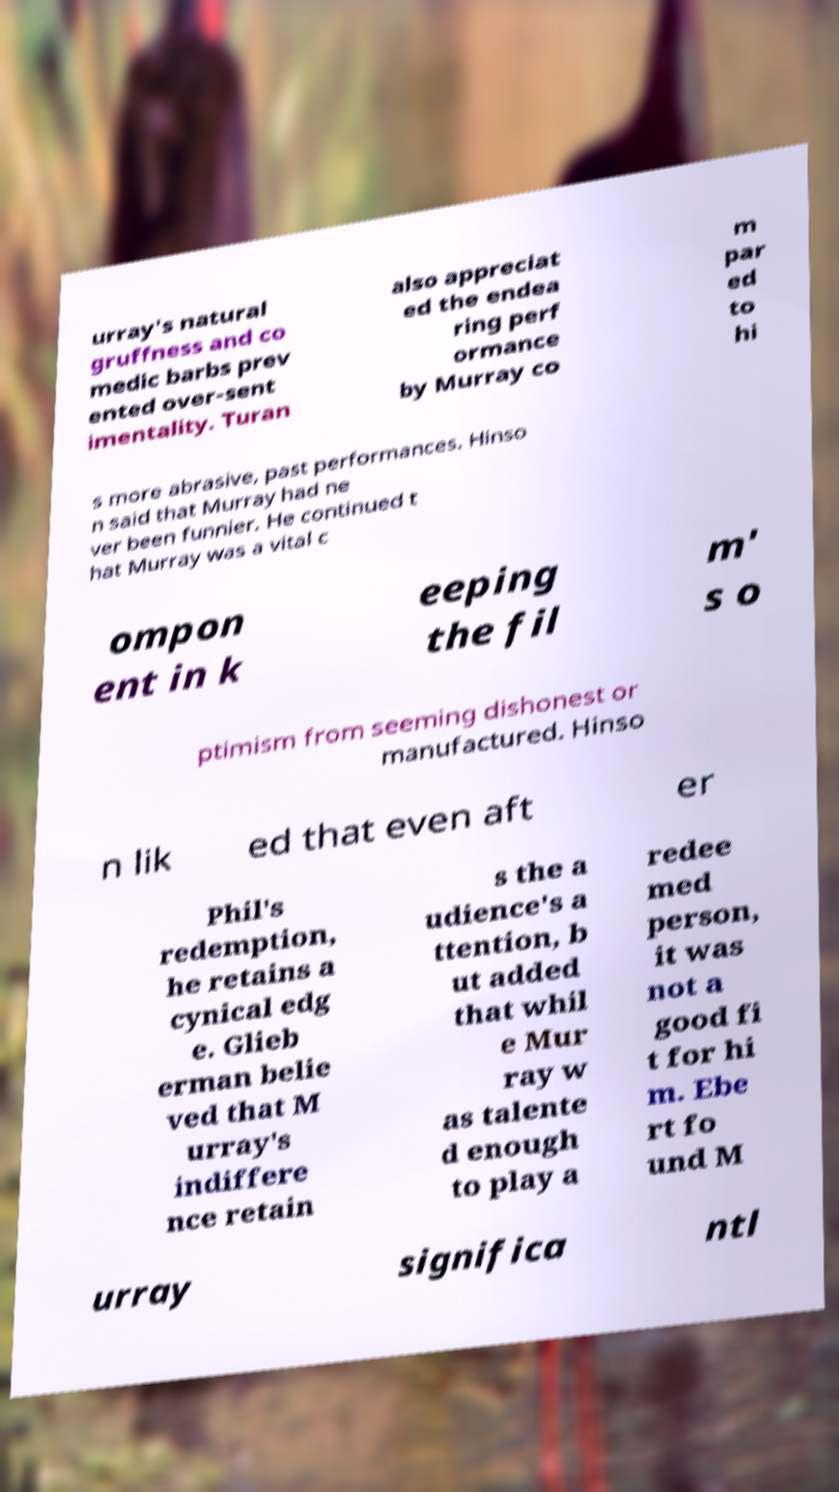Can you read and provide the text displayed in the image?This photo seems to have some interesting text. Can you extract and type it out for me? urray's natural gruffness and co medic barbs prev ented over-sent imentality. Turan also appreciat ed the endea ring perf ormance by Murray co m par ed to hi s more abrasive, past performances. Hinso n said that Murray had ne ver been funnier. He continued t hat Murray was a vital c ompon ent in k eeping the fil m' s o ptimism from seeming dishonest or manufactured. Hinso n lik ed that even aft er Phil's redemption, he retains a cynical edg e. Glieb erman belie ved that M urray's indiffere nce retain s the a udience's a ttention, b ut added that whil e Mur ray w as talente d enough to play a redee med person, it was not a good fi t for hi m. Ebe rt fo und M urray significa ntl 